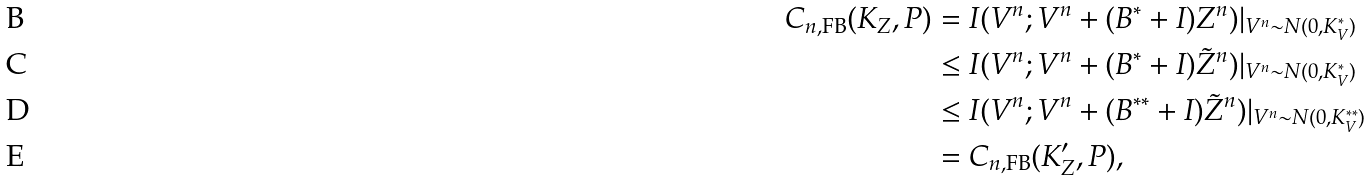<formula> <loc_0><loc_0><loc_500><loc_500>C _ { n , \text {FB} } ( K _ { Z } , P ) & = I ( V ^ { n } ; V ^ { n } + ( B ^ { * } + I ) Z ^ { n } ) | _ { V ^ { n } \sim N ( 0 , K _ { V } ^ { * } ) } \\ & \leq I ( V ^ { n } ; V ^ { n } + ( B ^ { * } + I ) \tilde { Z } ^ { n } ) | _ { V ^ { n } \sim N ( 0 , K _ { V } ^ { * } ) } \\ & \leq I ( V ^ { n } ; V ^ { n } + ( B ^ { * * } + I ) \tilde { Z } ^ { n } ) | _ { V ^ { n } \sim N ( 0 , K _ { V } ^ { * * } ) } \\ & = C _ { n , \text {FB} } ( { K } ^ { \prime } _ { Z } , P ) ,</formula> 